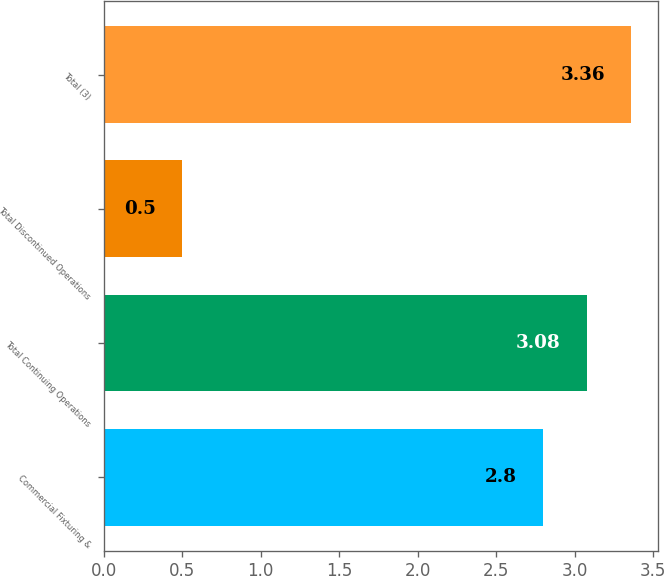Convert chart. <chart><loc_0><loc_0><loc_500><loc_500><bar_chart><fcel>Commercial Fixturing &<fcel>Total Continuing Operations<fcel>Total Discontinued Operations<fcel>Total (3)<nl><fcel>2.8<fcel>3.08<fcel>0.5<fcel>3.36<nl></chart> 